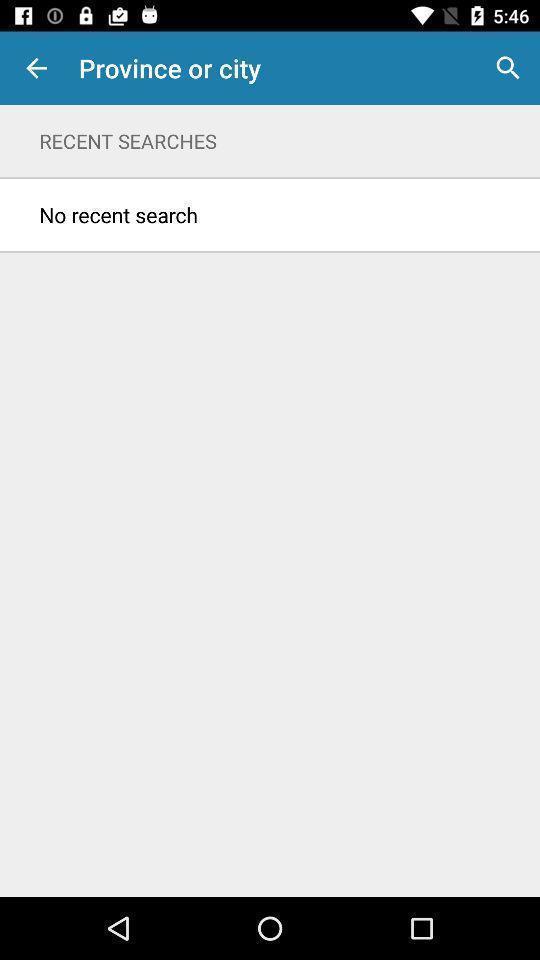Give me a narrative description of this picture. Page displaying the status of search. 